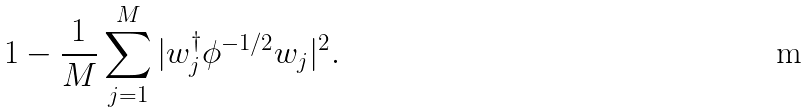Convert formula to latex. <formula><loc_0><loc_0><loc_500><loc_500>1 - \frac { 1 } { M } \sum _ { j = 1 } ^ { M } | w _ { j } ^ { \dag } \phi ^ { - 1 / 2 } w _ { j } | ^ { 2 } .</formula> 